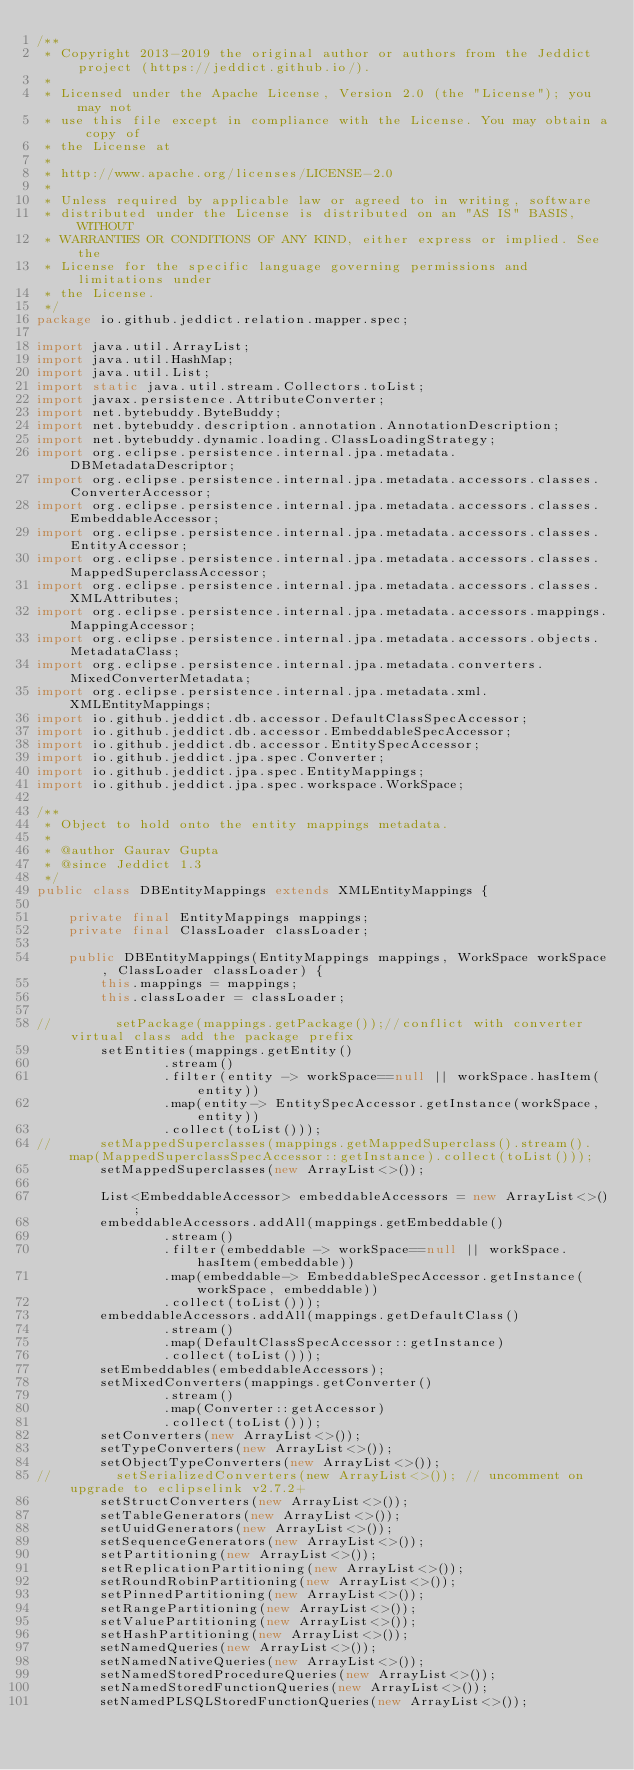Convert code to text. <code><loc_0><loc_0><loc_500><loc_500><_Java_>/**
 * Copyright 2013-2019 the original author or authors from the Jeddict project (https://jeddict.github.io/).
 *
 * Licensed under the Apache License, Version 2.0 (the "License"); you may not
 * use this file except in compliance with the License. You may obtain a copy of
 * the License at
 *
 * http://www.apache.org/licenses/LICENSE-2.0
 *
 * Unless required by applicable law or agreed to in writing, software
 * distributed under the License is distributed on an "AS IS" BASIS, WITHOUT
 * WARRANTIES OR CONDITIONS OF ANY KIND, either express or implied. See the
 * License for the specific language governing permissions and limitations under
 * the License.
 */
package io.github.jeddict.relation.mapper.spec;

import java.util.ArrayList;
import java.util.HashMap;
import java.util.List;
import static java.util.stream.Collectors.toList;
import javax.persistence.AttributeConverter;
import net.bytebuddy.ByteBuddy;
import net.bytebuddy.description.annotation.AnnotationDescription;
import net.bytebuddy.dynamic.loading.ClassLoadingStrategy;
import org.eclipse.persistence.internal.jpa.metadata.DBMetadataDescriptor;
import org.eclipse.persistence.internal.jpa.metadata.accessors.classes.ConverterAccessor;
import org.eclipse.persistence.internal.jpa.metadata.accessors.classes.EmbeddableAccessor;
import org.eclipse.persistence.internal.jpa.metadata.accessors.classes.EntityAccessor;
import org.eclipse.persistence.internal.jpa.metadata.accessors.classes.MappedSuperclassAccessor;
import org.eclipse.persistence.internal.jpa.metadata.accessors.classes.XMLAttributes;
import org.eclipse.persistence.internal.jpa.metadata.accessors.mappings.MappingAccessor;
import org.eclipse.persistence.internal.jpa.metadata.accessors.objects.MetadataClass;
import org.eclipse.persistence.internal.jpa.metadata.converters.MixedConverterMetadata;
import org.eclipse.persistence.internal.jpa.metadata.xml.XMLEntityMappings;
import io.github.jeddict.db.accessor.DefaultClassSpecAccessor;
import io.github.jeddict.db.accessor.EmbeddableSpecAccessor;
import io.github.jeddict.db.accessor.EntitySpecAccessor;
import io.github.jeddict.jpa.spec.Converter;
import io.github.jeddict.jpa.spec.EntityMappings;
import io.github.jeddict.jpa.spec.workspace.WorkSpace;

/**
 * Object to hold onto the entity mappings metadata.
 *
 * @author Gaurav Gupta
 * @since Jeddict 1.3
 */
public class DBEntityMappings extends XMLEntityMappings {

    private final EntityMappings mappings;
    private final ClassLoader classLoader;

    public DBEntityMappings(EntityMappings mappings, WorkSpace workSpace, ClassLoader classLoader) {
        this.mappings = mappings;
        this.classLoader = classLoader;

//        setPackage(mappings.getPackage());//conflict with converter virtual class add the package prefix
        setEntities(mappings.getEntity()
                .stream()
                .filter(entity -> workSpace==null || workSpace.hasItem(entity))
                .map(entity-> EntitySpecAccessor.getInstance(workSpace, entity))
                .collect(toList()));
//      setMappedSuperclasses(mappings.getMappedSuperclass().stream().map(MappedSuperclassSpecAccessor::getInstance).collect(toList()));
        setMappedSuperclasses(new ArrayList<>());

        List<EmbeddableAccessor> embeddableAccessors = new ArrayList<>();
        embeddableAccessors.addAll(mappings.getEmbeddable()
                .stream()
                .filter(embeddable -> workSpace==null || workSpace.hasItem(embeddable))
                .map(embeddable-> EmbeddableSpecAccessor.getInstance(workSpace, embeddable))
                .collect(toList()));
        embeddableAccessors.addAll(mappings.getDefaultClass()
                .stream()
                .map(DefaultClassSpecAccessor::getInstance)
                .collect(toList()));
        setEmbeddables(embeddableAccessors);
        setMixedConverters(mappings.getConverter()
                .stream()
                .map(Converter::getAccessor)
                .collect(toList()));
        setConverters(new ArrayList<>());
        setTypeConverters(new ArrayList<>());
        setObjectTypeConverters(new ArrayList<>());
//        setSerializedConverters(new ArrayList<>()); // uncomment on upgrade to eclipselink v2.7.2+
        setStructConverters(new ArrayList<>());
        setTableGenerators(new ArrayList<>());
        setUuidGenerators(new ArrayList<>());
        setSequenceGenerators(new ArrayList<>());
        setPartitioning(new ArrayList<>());
        setReplicationPartitioning(new ArrayList<>());
        setRoundRobinPartitioning(new ArrayList<>());
        setPinnedPartitioning(new ArrayList<>());
        setRangePartitioning(new ArrayList<>());
        setValuePartitioning(new ArrayList<>());
        setHashPartitioning(new ArrayList<>());
        setNamedQueries(new ArrayList<>());
        setNamedNativeQueries(new ArrayList<>());
        setNamedStoredProcedureQueries(new ArrayList<>());
        setNamedStoredFunctionQueries(new ArrayList<>());
        setNamedPLSQLStoredFunctionQueries(new ArrayList<>());</code> 